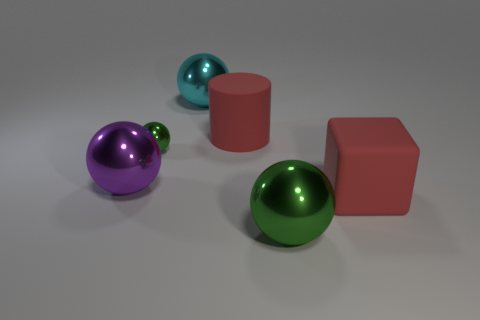Can you describe the colors of the objects shown and how they might affect the perception of the scene? Certainly! The image features a collection of geometric objects with distinct colors: a vibrant green and a deep purple for the two spheres, and a muted teal for the smallest sphere. The larger cube-like shapes are in shades of pink and red. The use of these bold colors against the neutral background increases the visual contrast, making the objects stand out and giving the composition a lively, dynamic quality. 